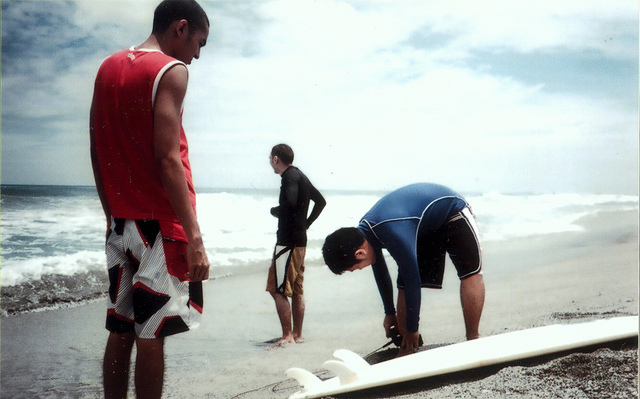How many boys are in this photo? There appear to be three individuals who could be considered boys, each engaged in different activities by the shore. One is standing and looking towards the ocean, another is slightly bent with his hands on his waist also looking out at the sea, and the third is crouched down adjusting a surfboard. 